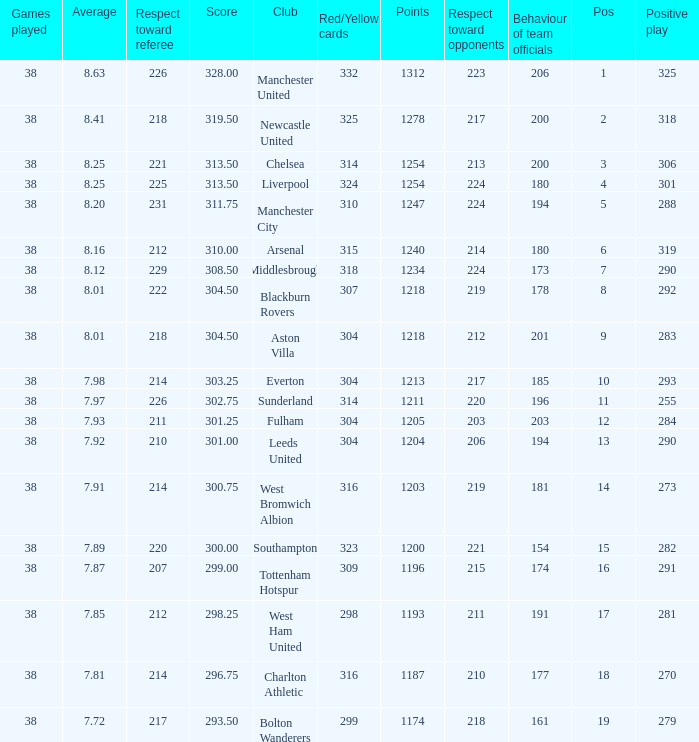Name the most pos for west bromwich albion club 14.0. 